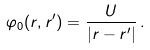Convert formula to latex. <formula><loc_0><loc_0><loc_500><loc_500>\varphi _ { 0 } ( r , r ^ { \prime } ) = \frac { U } { | r - r ^ { \prime } | } \, .</formula> 